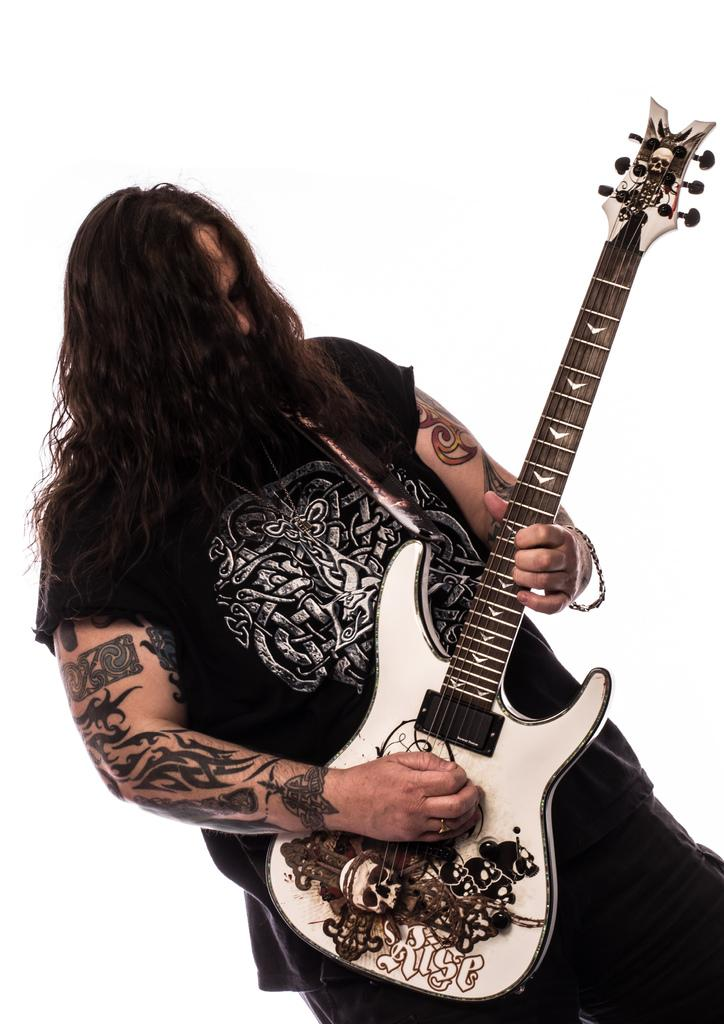Who is the main subject in the picture? There is a man in the picture. What is the man holding in the picture? The man is holding a guitar. What is the man's posture in the picture? The man is standing. What is the color of the background in the picture? There is a white background in the picture. What type of produce can be seen in the picture? There is no produce present in the picture; it features a man holding a guitar against a white background. Can you tell me how many kittens are sitting on the guitar in the picture? There are no kittens present in the picture; it only features a man holding a guitar against a white background. 